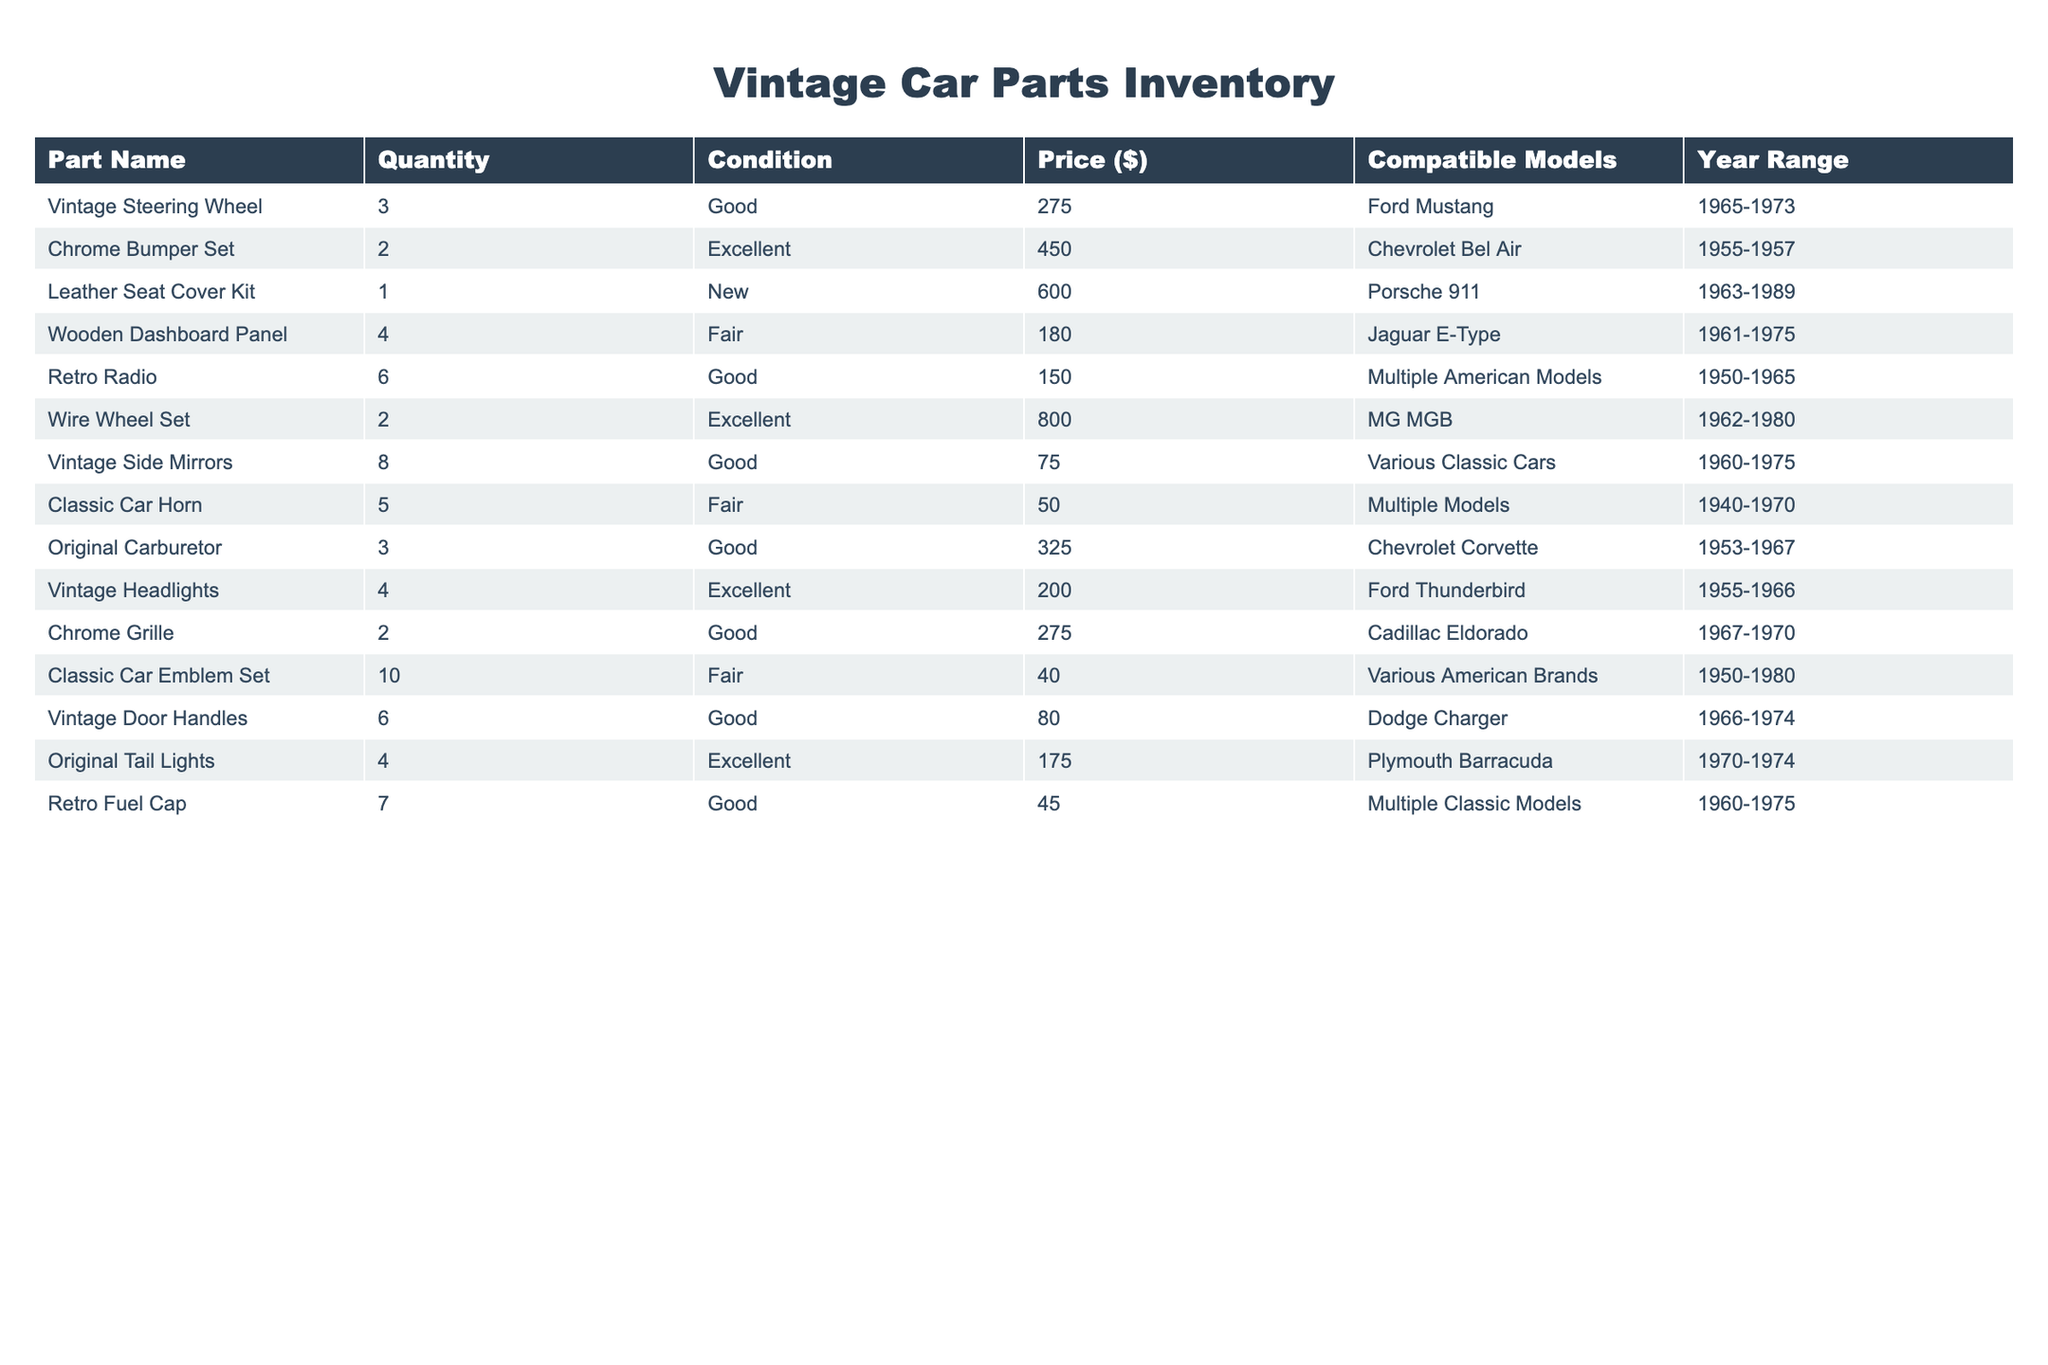What is the total quantity of Vintage Side Mirrors available? From the table, the quantity of Vintage Side Mirrors is listed as 8. This is a direct retrieval from the specific row and column for that part.
Answer: 8 How many parts are in 'Excellent' condition? The table shows there are 5 parts listed in 'Excellent' condition. Specifically, they are the Chrome Bumper Set, Wire Wheel Set, Vintage Headlights, Original Tail Lights, and Leather Seat Cover Kit.
Answer: 5 What is the price of the Vintage Steering Wheel? The price for the Vintage Steering Wheel is listed in the table under the Price column, which shows $275.
Answer: 275 What is the average price of parts in 'Fair' condition? The prices for 'Fair' condition parts are 180, 50, and 40. To find the average, we sum these prices (180 + 50 + 40 = 270) and divide by the number of parts (3), giving us an average price of 90.
Answer: 90 Do any parts have a quantity greater than 5? Looking through the table, the Classic Car Emblem Set and Vintage Side Mirrors both have quantities of 10 and 8, respectively. Thus, the answer is yes.
Answer: Yes How much is the Vintage Headlights compared to the Leather Seat Cover Kit? The Vintage Headlights cost $200 and the Leather Seat Cover Kit costs $600. The difference is calculated as 600 - 200 = 400. Therefore, the Leather Seat Cover Kit is $400 more expensive.
Answer: 400 Which part has the highest price, and what is it? By scanning the Price column, the highest price listed is $800 for the Wire Wheel Set. This is a retrieval of the maximum value found in that column.
Answer: Wire Wheel Set, 800 What is the total cost of all parts in 'Good' condition? The parts in 'Good' condition are priced at 275, 150, 75, 325, 200, 275, 80, and 45. Summing these gives (275 + 150 + 75 + 325 + 200 + 275 + 80 + 45 = 1425). Therefore, the total cost of parts in 'Good' condition is $1425.
Answer: 1425 How many parts from the table are compatible with models from 1960 to 1975? The parts compatible with models from 1960 to 1975 are the Vintage Side Mirrors, Chrome Grille, Vintage Steering Wheel, and Original Tail Lights. Summing these gives 4 parts that are compatible with that model range.
Answer: 4 Is there any part that is compatible with multiple models, and if so, which one? Yes, the Retro Radio is listed as compatible with "Multiple American Models" in the Compatible Models column. Thus, this part fits the criteria.
Answer: Yes, Retro Radio 